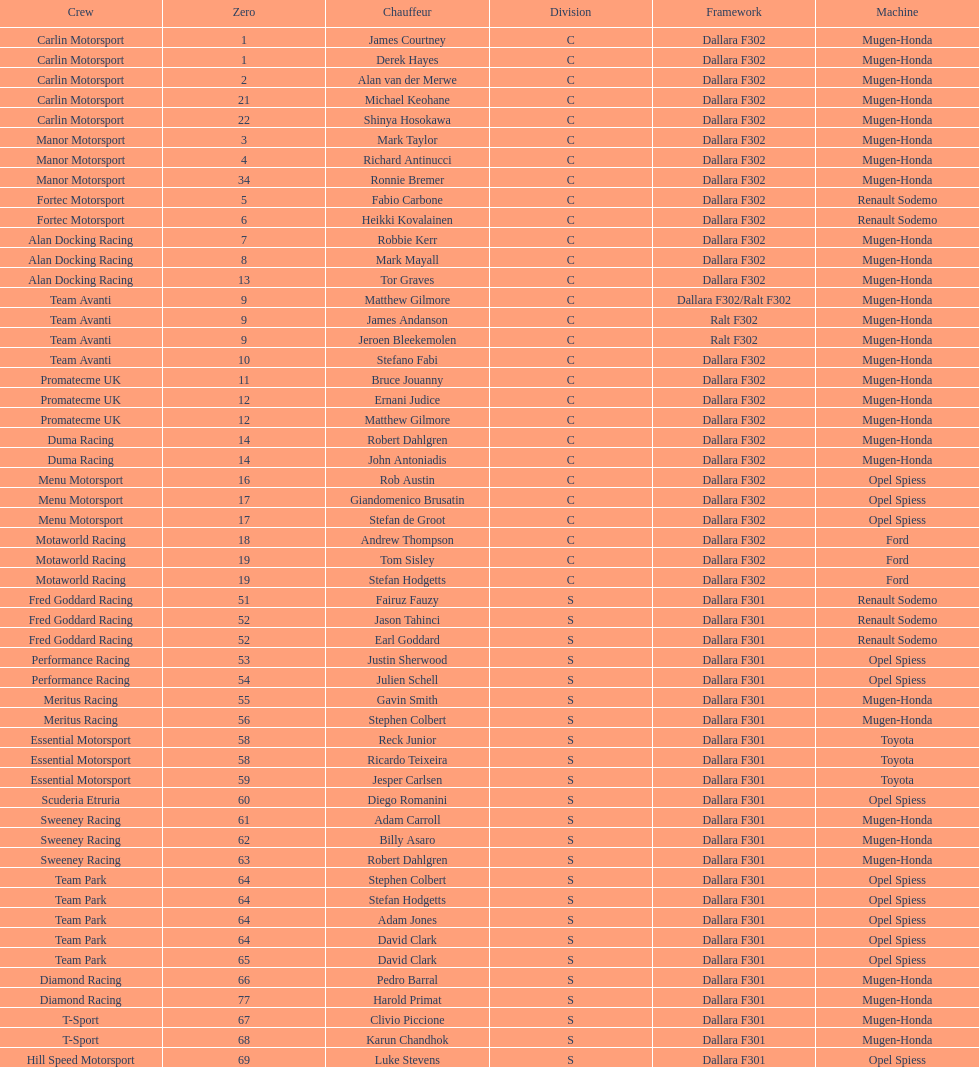What is the average number of teams that had a mugen-honda engine? 24. 